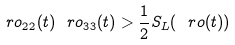<formula> <loc_0><loc_0><loc_500><loc_500>\ r o _ { 2 2 } ( t ) \ r o _ { 3 3 } ( t ) > \frac { 1 } { 2 } S _ { L } ( \ r o ( t ) )</formula> 